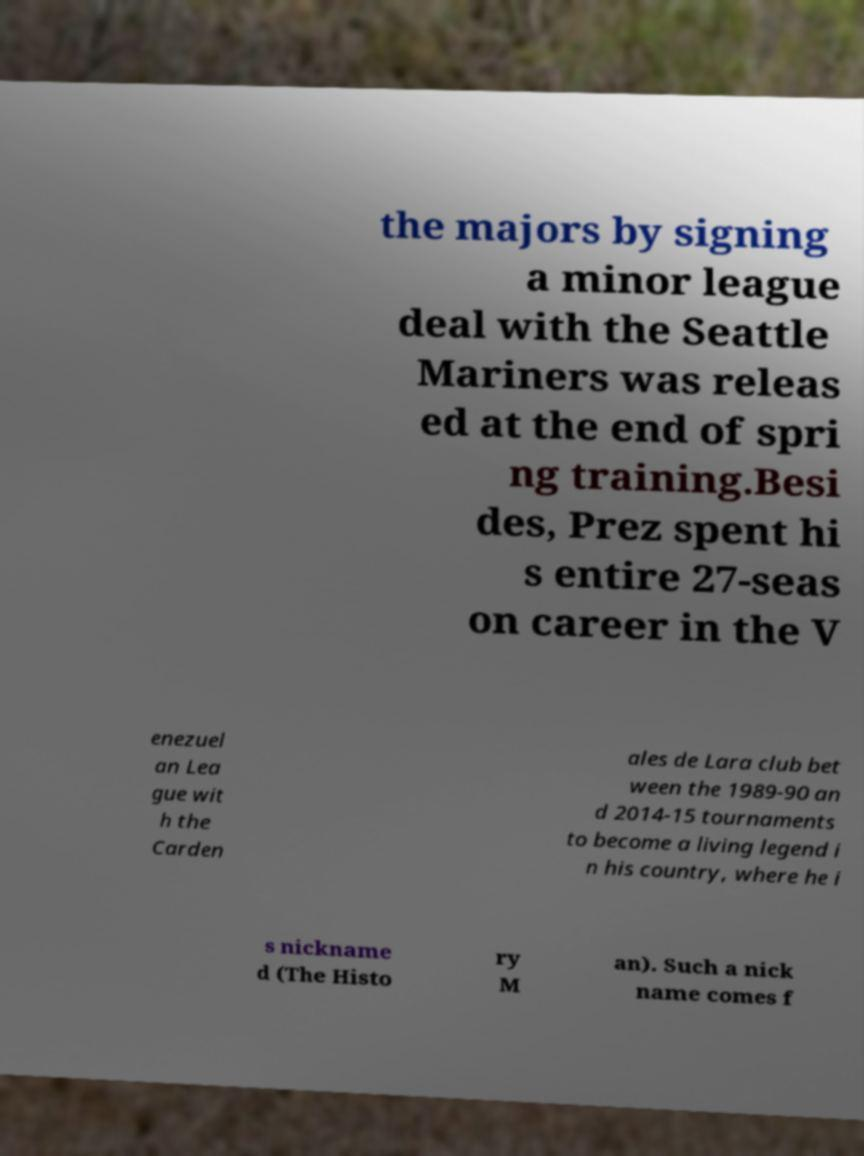Could you assist in decoding the text presented in this image and type it out clearly? the majors by signing a minor league deal with the Seattle Mariners was releas ed at the end of spri ng training.Besi des, Prez spent hi s entire 27-seas on career in the V enezuel an Lea gue wit h the Carden ales de Lara club bet ween the 1989-90 an d 2014-15 tournaments to become a living legend i n his country, where he i s nickname d (The Histo ry M an). Such a nick name comes f 